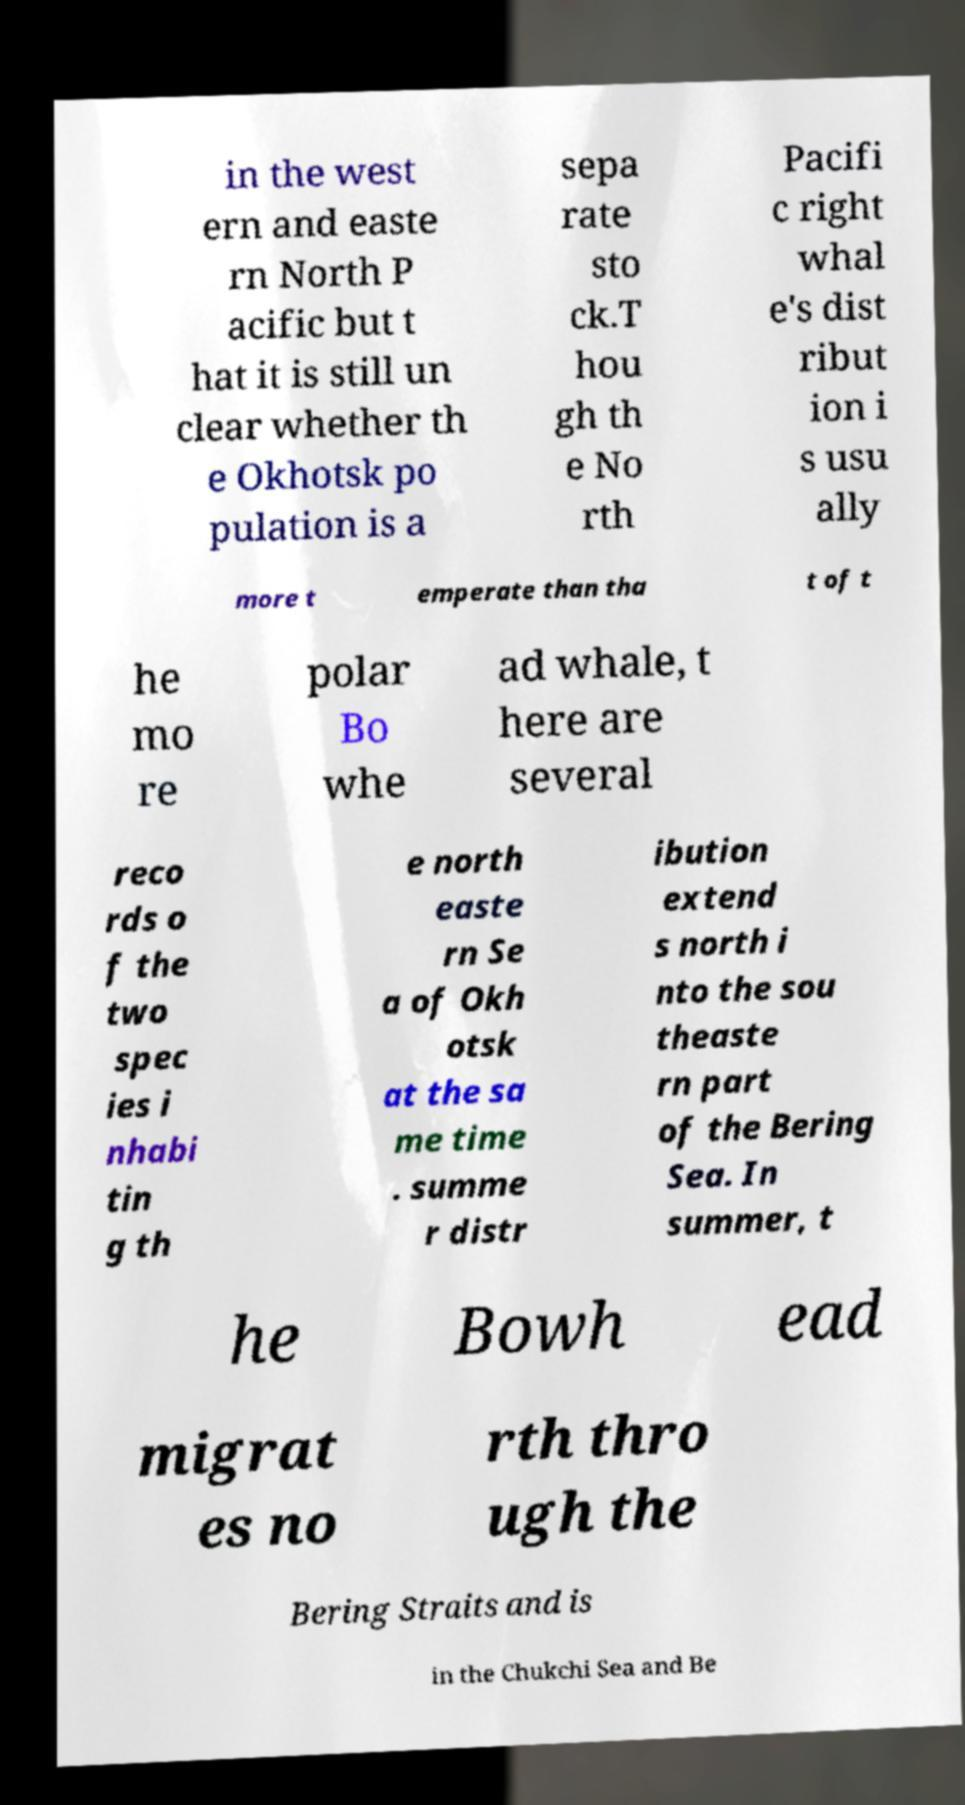There's text embedded in this image that I need extracted. Can you transcribe it verbatim? in the west ern and easte rn North P acific but t hat it is still un clear whether th e Okhotsk po pulation is a sepa rate sto ck.T hou gh th e No rth Pacifi c right whal e's dist ribut ion i s usu ally more t emperate than tha t of t he mo re polar Bo whe ad whale, t here are several reco rds o f the two spec ies i nhabi tin g th e north easte rn Se a of Okh otsk at the sa me time . summe r distr ibution extend s north i nto the sou theaste rn part of the Bering Sea. In summer, t he Bowh ead migrat es no rth thro ugh the Bering Straits and is in the Chukchi Sea and Be 